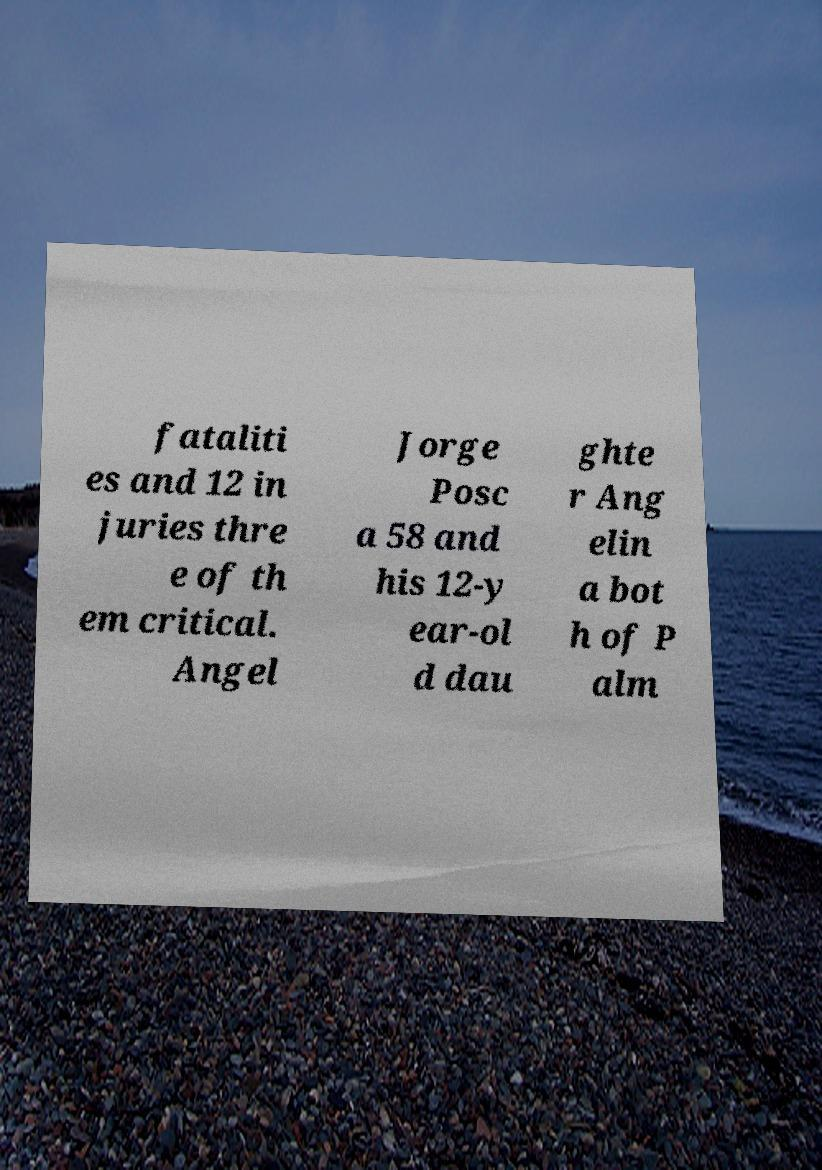Could you extract and type out the text from this image? fataliti es and 12 in juries thre e of th em critical. Angel Jorge Posc a 58 and his 12-y ear-ol d dau ghte r Ang elin a bot h of P alm 